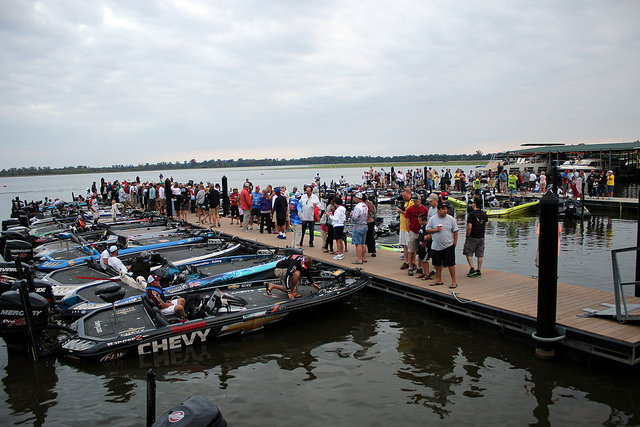Please identify all text content in this image. CHEVY 